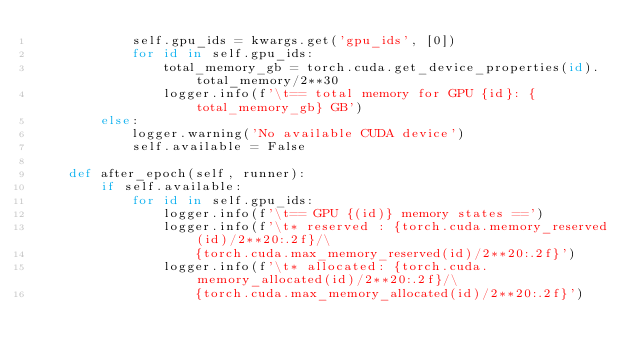Convert code to text. <code><loc_0><loc_0><loc_500><loc_500><_Python_>            self.gpu_ids = kwargs.get('gpu_ids', [0])
            for id in self.gpu_ids:
                total_memory_gb = torch.cuda.get_device_properties(id).total_memory/2**30
                logger.info(f'\t== total memory for GPU {id}: {total_memory_gb} GB')
        else:
            logger.warning('No available CUDA device')
            self.available = False

    def after_epoch(self, runner):
        if self.available:
            for id in self.gpu_ids:
                logger.info(f'\t== GPU {(id)} memory states ==')
                logger.info(f'\t* reserved : {torch.cuda.memory_reserved(id)/2**20:.2f}/\
                    {torch.cuda.max_memory_reserved(id)/2**20:.2f}')
                logger.info(f'\t* allocated: {torch.cuda.memory_allocated(id)/2**20:.2f}/\
                    {torch.cuda.max_memory_allocated(id)/2**20:.2f}')
</code> 